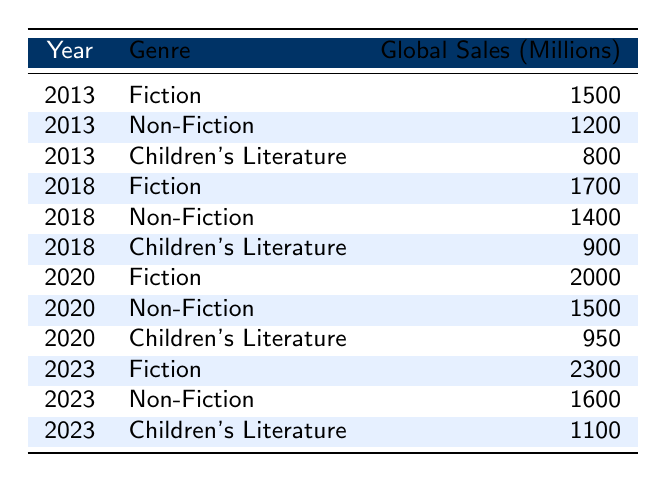What was the total global sales in millions for Fiction in 2020? The table shows that in 2020, the global sales for Fiction were 2000 million.
Answer: 2000 Which genre had the highest global sales in 2023? In 2023, the global sales for Fiction were 2300 million, for Non-Fiction were 1600 million, and for Children's Literature were 1100 million. Fiction had the highest sales.
Answer: Fiction What is the difference in global sales for Non-Fiction from 2013 to 2023? In 2013, Non-Fiction sales were 1200 million, and in 2023, they were 1600 million. The difference is 1600 - 1200 = 400 million.
Answer: 400 Is it true that Children's Literature sales in 2023 are greater than in 2018? In 2018, Children's Literature sales were 900 million, and in 2023, they were 1100 million. Since 1100 is greater than 900, the statement is true.
Answer: Yes What was the average global sales in millions for Fiction over the years 2013, 2018, 2020, and 2023? The total Fiction sales for these years are 1500 (2013) + 1700 (2018) + 2000 (2020) + 2300 (2023) = 8500 million. There are 4 data points, so the average is 8500 / 4 = 2125 million.
Answer: 2125 What were the global sales trends for Children's Literature from 2013 to 2023? In 2013, sales were 800 million, in 2018 they increased to 900 million, in 2020 they rose to 950 million, and in 2023 they reached 1100 million. This indicates a positive trend over the years.
Answer: Positive trend Was the global sales for Non-Fiction higher in 2020 compared to 2018? In 2018, Non-Fiction sales were 1400 million, and in 2020, they rose to 1500 million. Since 1500 is greater than 1400, the sales were indeed higher in 2020.
Answer: Yes What is the total global sales for all genres combined in 2013? The total sales in 2013 are calculated by adding the sales for each genre: 1500 (Fiction) + 1200 (Non-Fiction) + 800 (Children's Literature) = 3500 million.
Answer: 3500 What was the highest global sales figure recorded for any genre in the entire table? The highest figure is 2300 million for Fiction in 2023.
Answer: 2300 